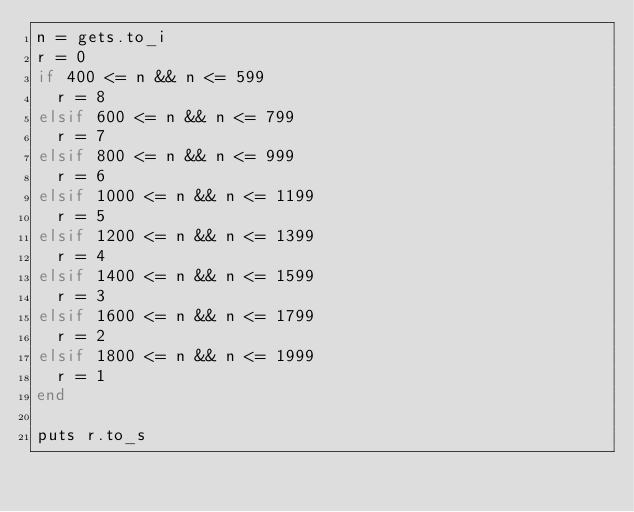<code> <loc_0><loc_0><loc_500><loc_500><_Ruby_>n = gets.to_i
r = 0
if 400 <= n && n <= 599
  r = 8
elsif 600 <= n && n <= 799
  r = 7
elsif 800 <= n && n <= 999
  r = 6
elsif 1000 <= n && n <= 1199
  r = 5
elsif 1200 <= n && n <= 1399
  r = 4
elsif 1400 <= n && n <= 1599
  r = 3
elsif 1600 <= n && n <= 1799
  r = 2
elsif 1800 <= n && n <= 1999
  r = 1
end

puts r.to_s</code> 